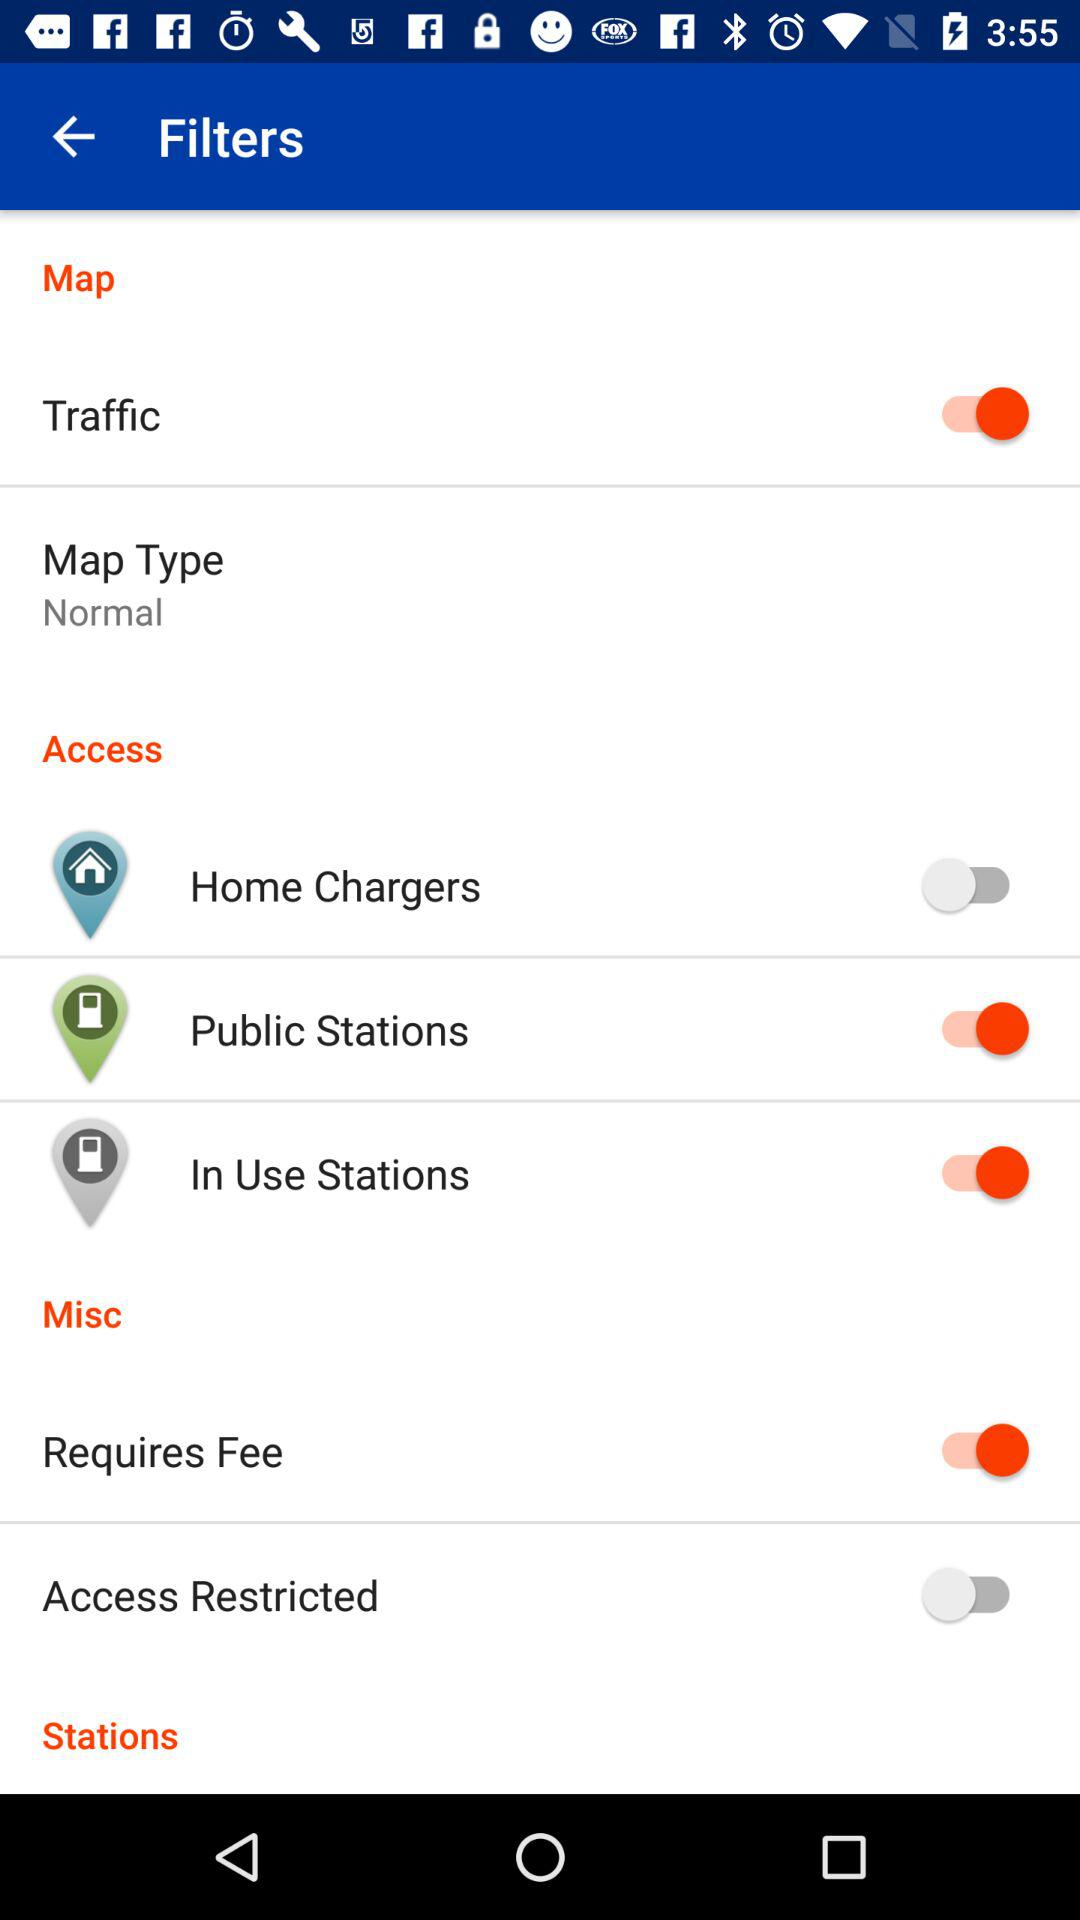What is the status of "In Use Stations"? The status of "In Use Stations" is "on". 